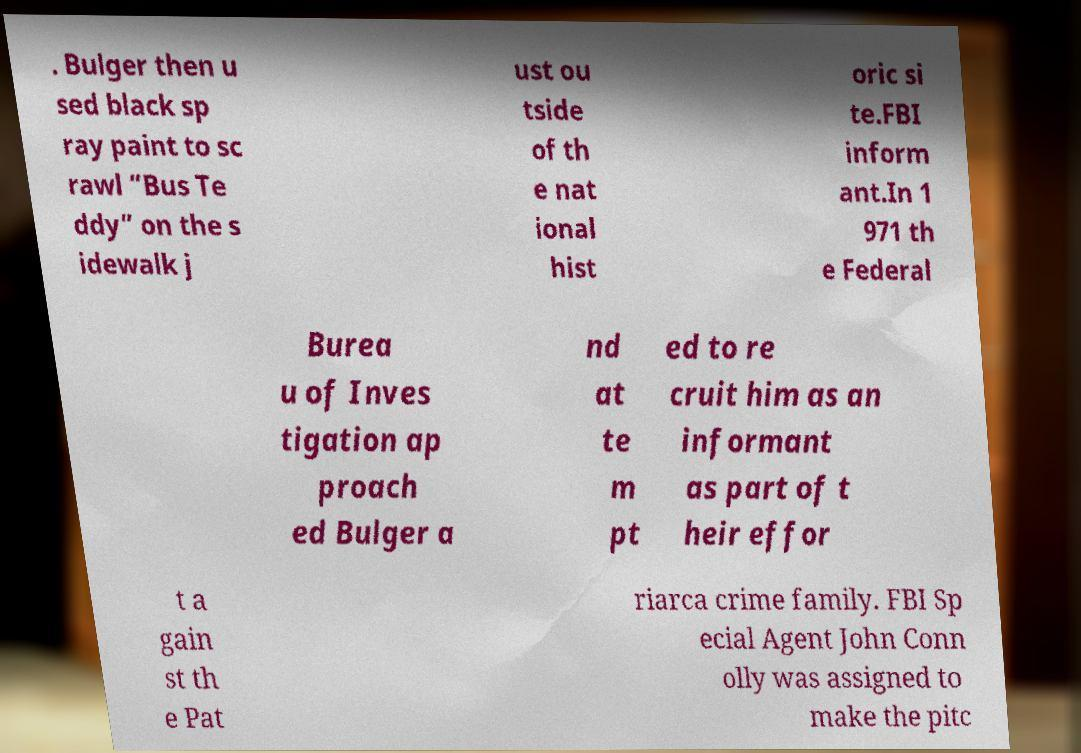Can you read and provide the text displayed in the image?This photo seems to have some interesting text. Can you extract and type it out for me? . Bulger then u sed black sp ray paint to sc rawl “Bus Te ddy” on the s idewalk j ust ou tside of th e nat ional hist oric si te.FBI inform ant.In 1 971 th e Federal Burea u of Inves tigation ap proach ed Bulger a nd at te m pt ed to re cruit him as an informant as part of t heir effor t a gain st th e Pat riarca crime family. FBI Sp ecial Agent John Conn olly was assigned to make the pitc 